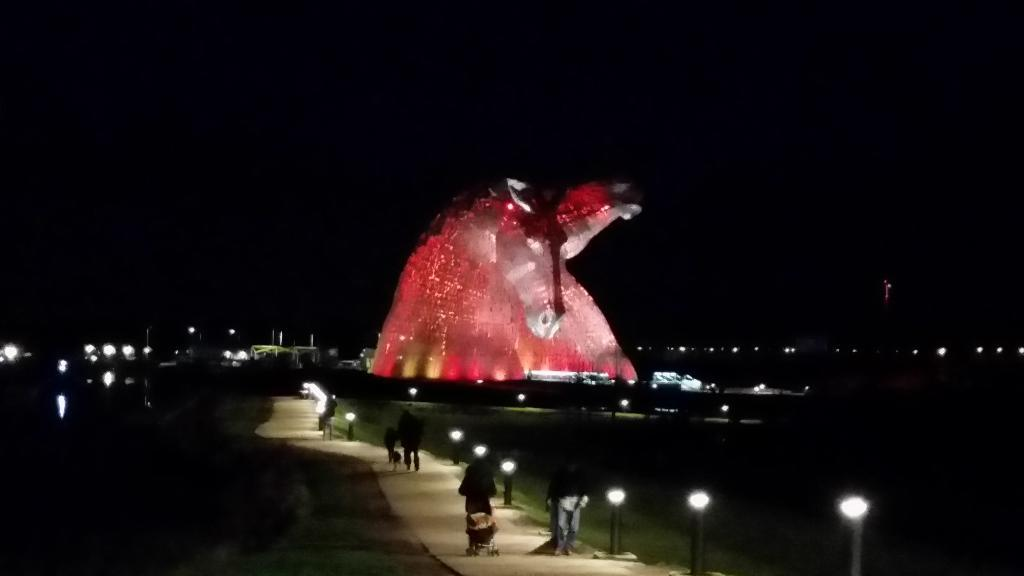What is the main object in the center of the image? There is an object with lights in the center of the image. What are the people in the image doing? The people in the image are walking on a path. What type of vegetation can be seen in the image? There is grass visible in the image. What provides additional lighting in the image? There are light poles present in the image. How many kitties are sleeping on the beds in the image? There are no kitties or beds present in the image. What type of team is visible in the image? There is no team visible in the image. 